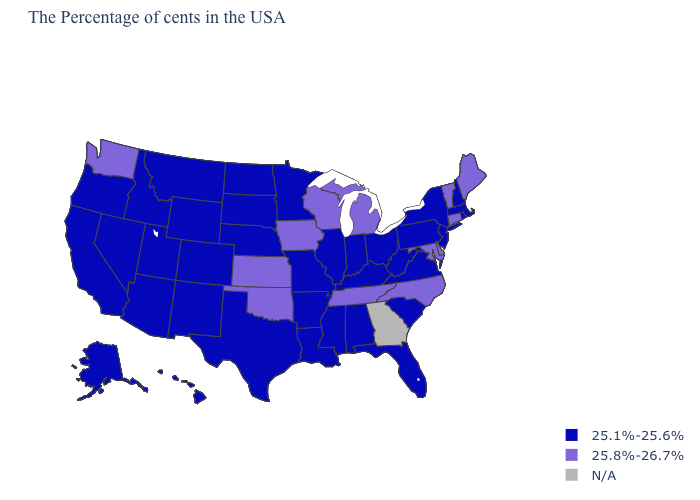Among the states that border Minnesota , which have the highest value?
Concise answer only. Wisconsin, Iowa. Which states have the lowest value in the MidWest?
Concise answer only. Ohio, Indiana, Illinois, Missouri, Minnesota, Nebraska, South Dakota, North Dakota. What is the value of Arkansas?
Be succinct. 25.1%-25.6%. What is the value of South Carolina?
Concise answer only. 25.1%-25.6%. Does Massachusetts have the highest value in the USA?
Answer briefly. No. Name the states that have a value in the range N/A?
Give a very brief answer. Georgia. Does South Carolina have the highest value in the USA?
Give a very brief answer. No. Name the states that have a value in the range 25.1%-25.6%?
Keep it brief. Massachusetts, Rhode Island, New Hampshire, New York, New Jersey, Pennsylvania, Virginia, South Carolina, West Virginia, Ohio, Florida, Kentucky, Indiana, Alabama, Illinois, Mississippi, Louisiana, Missouri, Arkansas, Minnesota, Nebraska, Texas, South Dakota, North Dakota, Wyoming, Colorado, New Mexico, Utah, Montana, Arizona, Idaho, Nevada, California, Oregon, Alaska, Hawaii. What is the value of Louisiana?
Concise answer only. 25.1%-25.6%. Name the states that have a value in the range 25.8%-26.7%?
Keep it brief. Maine, Vermont, Connecticut, Delaware, Maryland, North Carolina, Michigan, Tennessee, Wisconsin, Iowa, Kansas, Oklahoma, Washington. What is the value of Montana?
Be succinct. 25.1%-25.6%. Which states hav the highest value in the MidWest?
Quick response, please. Michigan, Wisconsin, Iowa, Kansas. What is the highest value in states that border Pennsylvania?
Short answer required. 25.8%-26.7%. What is the lowest value in states that border Wyoming?
Quick response, please. 25.1%-25.6%. 